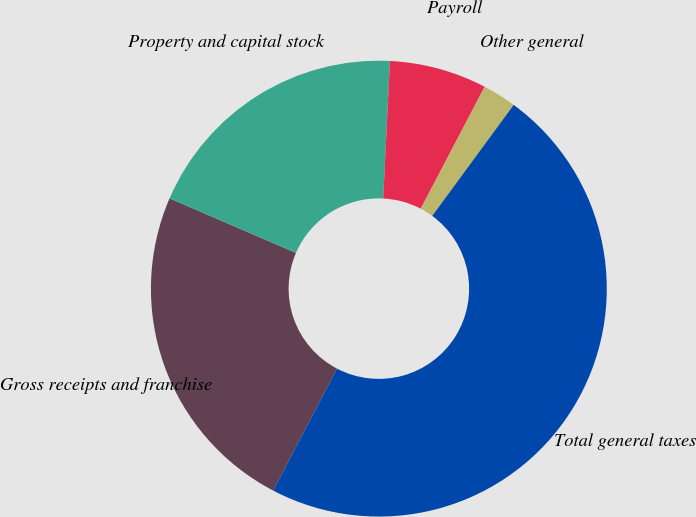Convert chart to OTSL. <chart><loc_0><loc_0><loc_500><loc_500><pie_chart><fcel>Gross receipts and franchise<fcel>Property and capital stock<fcel>Payroll<fcel>Other general<fcel>Total general taxes<nl><fcel>23.81%<fcel>19.29%<fcel>6.91%<fcel>2.39%<fcel>47.59%<nl></chart> 